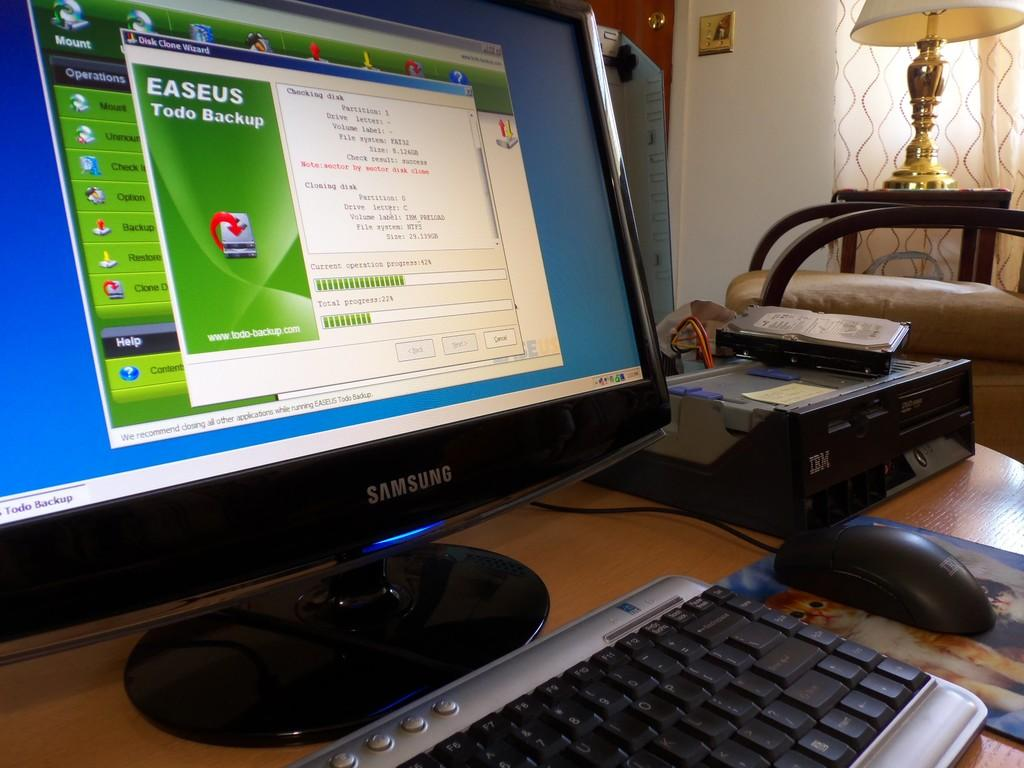<image>
Summarize the visual content of the image. the word operations is on the computer screen 